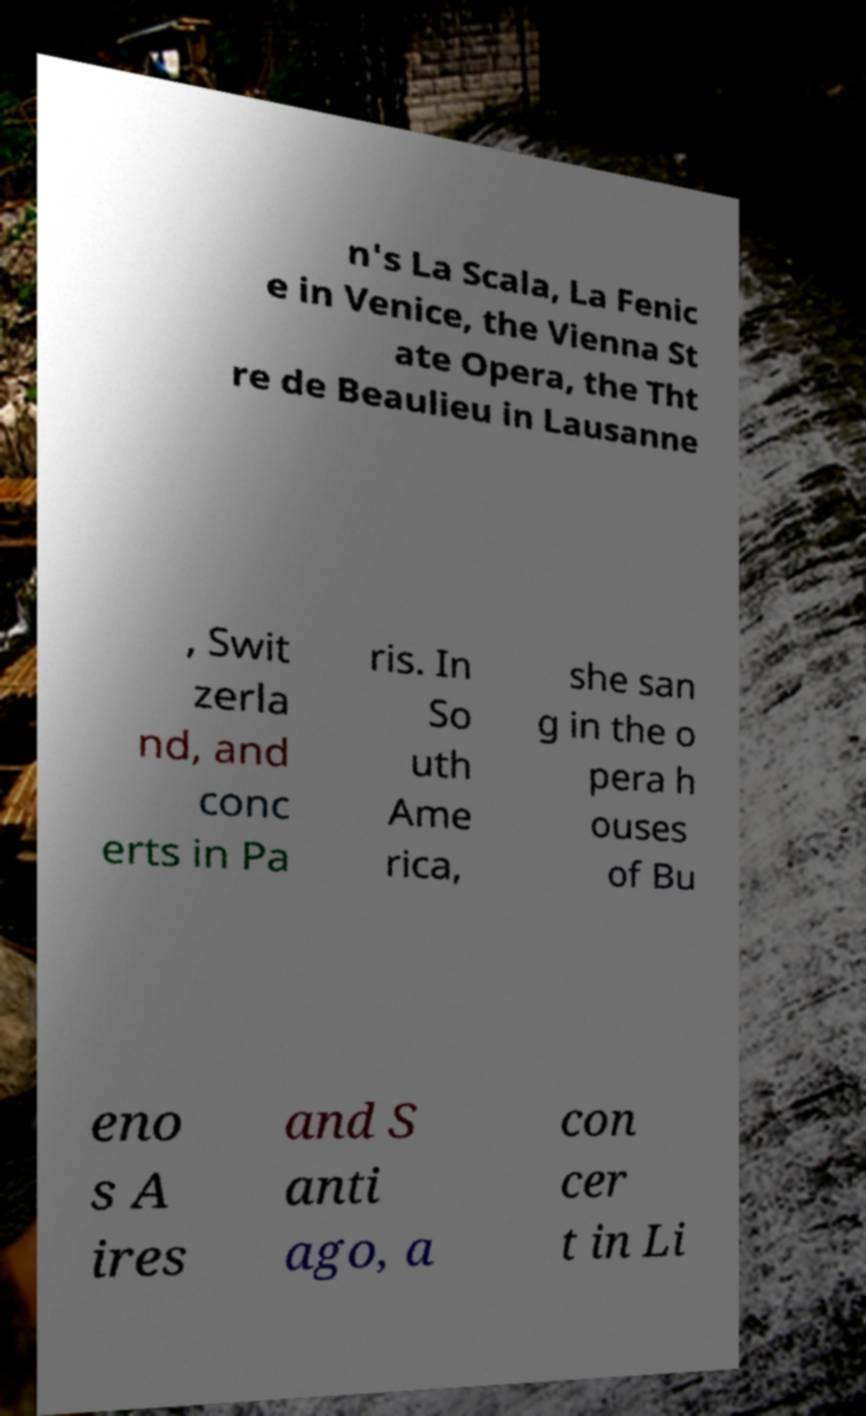Could you assist in decoding the text presented in this image and type it out clearly? n's La Scala, La Fenic e in Venice, the Vienna St ate Opera, the Tht re de Beaulieu in Lausanne , Swit zerla nd, and conc erts in Pa ris. In So uth Ame rica, she san g in the o pera h ouses of Bu eno s A ires and S anti ago, a con cer t in Li 